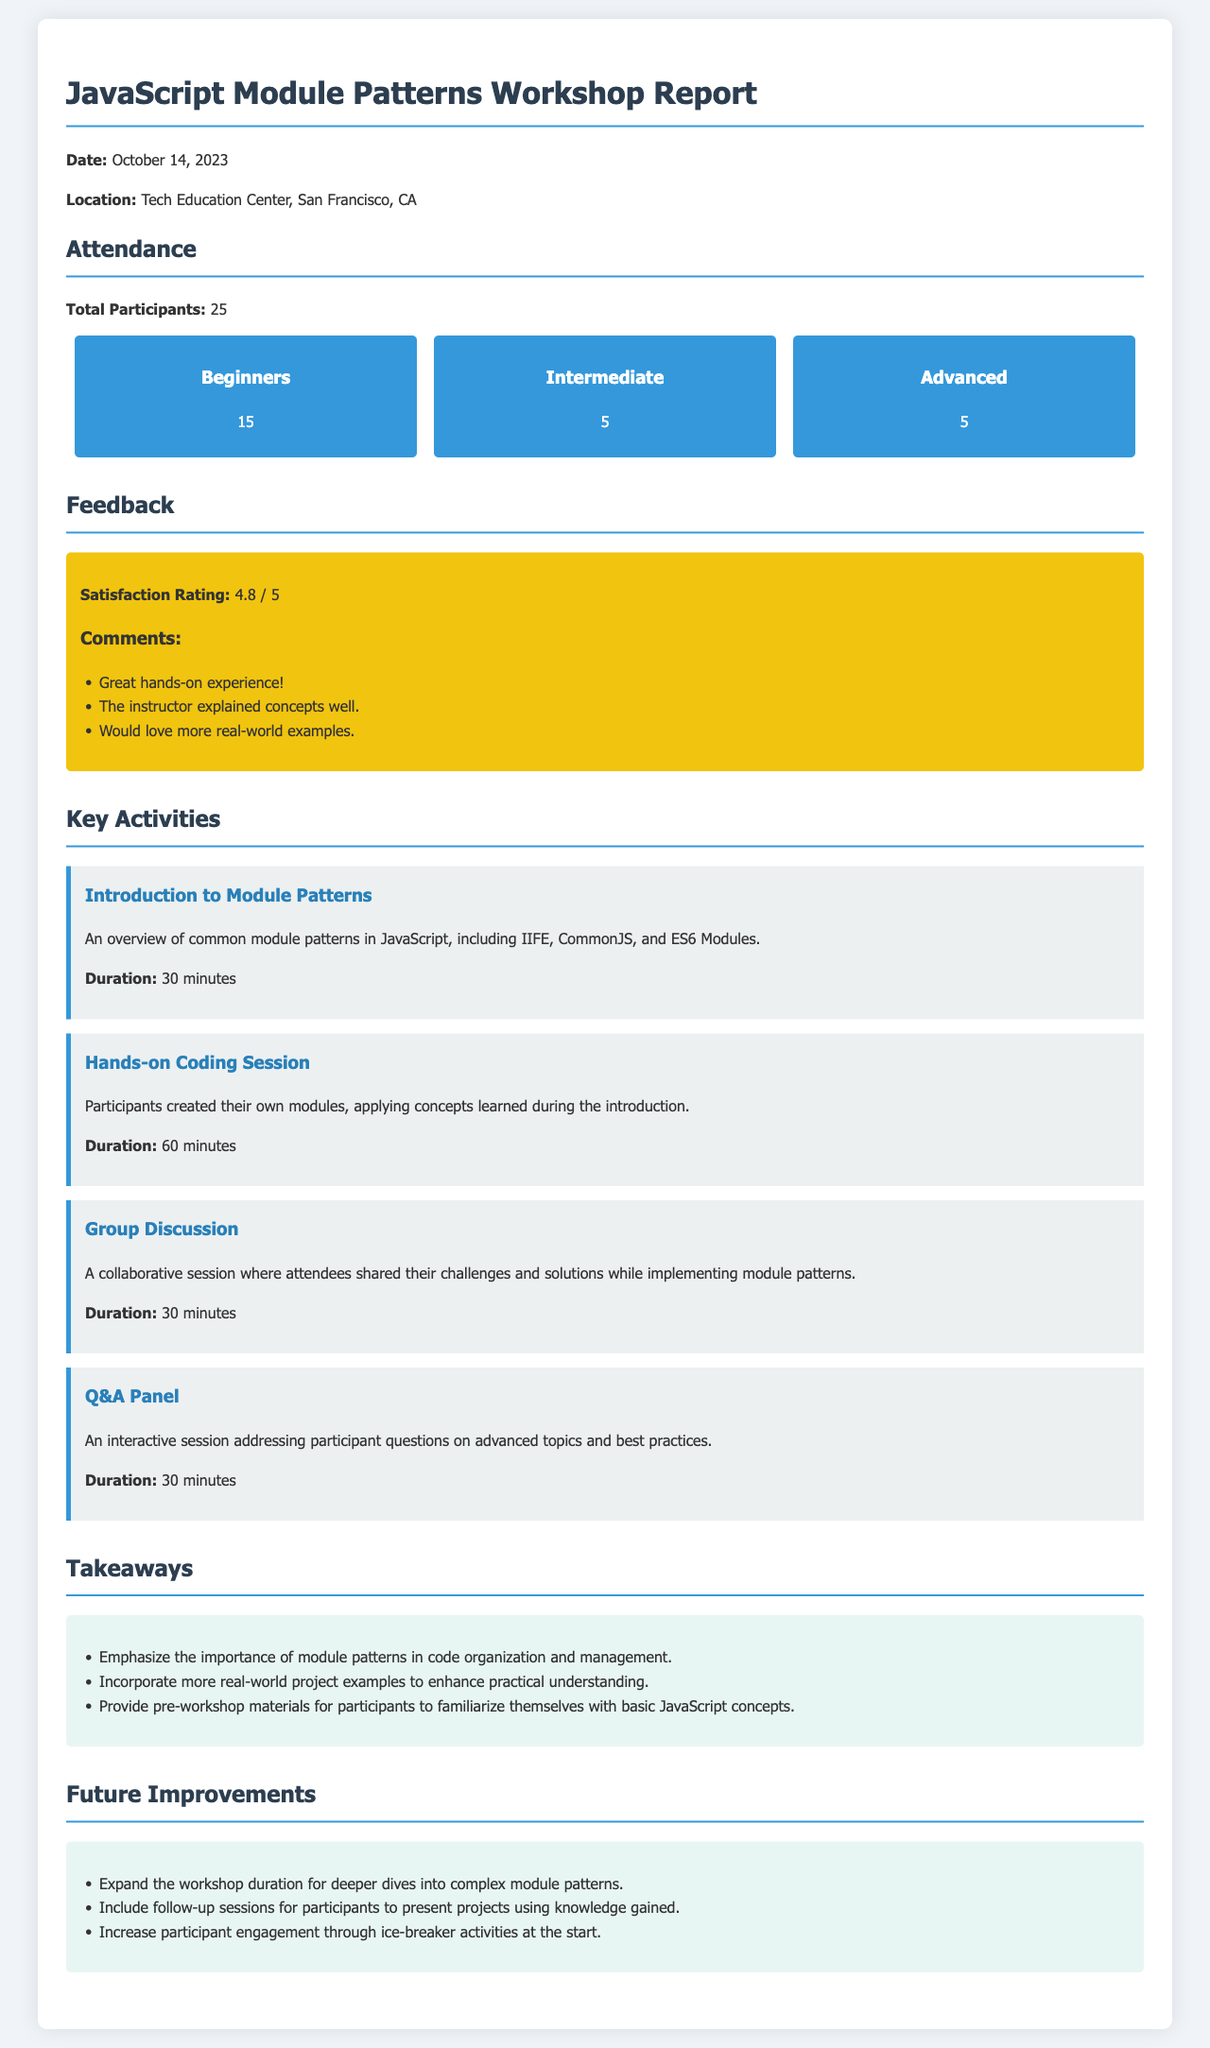What was the date of the workshop? The date of the workshop is mentioned at the beginning of the report.
Answer: October 14, 2023 How many total participants attended the workshop? The total number of participants is specified in the attendance section of the report.
Answer: 25 What was the satisfaction rating given by participants? The satisfaction rating is provided in the feedback section.
Answer: 4.8 / 5 How many beginners participated in the workshop? The number of beginners can be found in the demographics section.
Answer: 15 What is one key takeaway from the workshop? Key takeaways are listed in the takeaways section; one example is being provided for conciseness.
Answer: Emphasize the importance of module patterns in code organization and management What activity had a duration of 60 minutes? The activity section lists all activities with their respective durations; this one stands out.
Answer: Hands-on Coding Session What suggestion was made for future improvements regarding session duration? Future improvements are outlined clearly, and one suggestion can be directly identified.
Answer: Expand the workshop duration for deeper dives into complex module patterns What was the feedback comment about the instructor's explanation? Feedback comments show specific opinions about the instructor, one of which is relevant here.
Answer: The instructor explained concepts well What type of sessions did participants wish to see more of in the future? The future improvements section mentions follow-up sessions, indicating a need expressed by participants.
Answer: Include follow-up sessions for participants to present projects using knowledge gained 